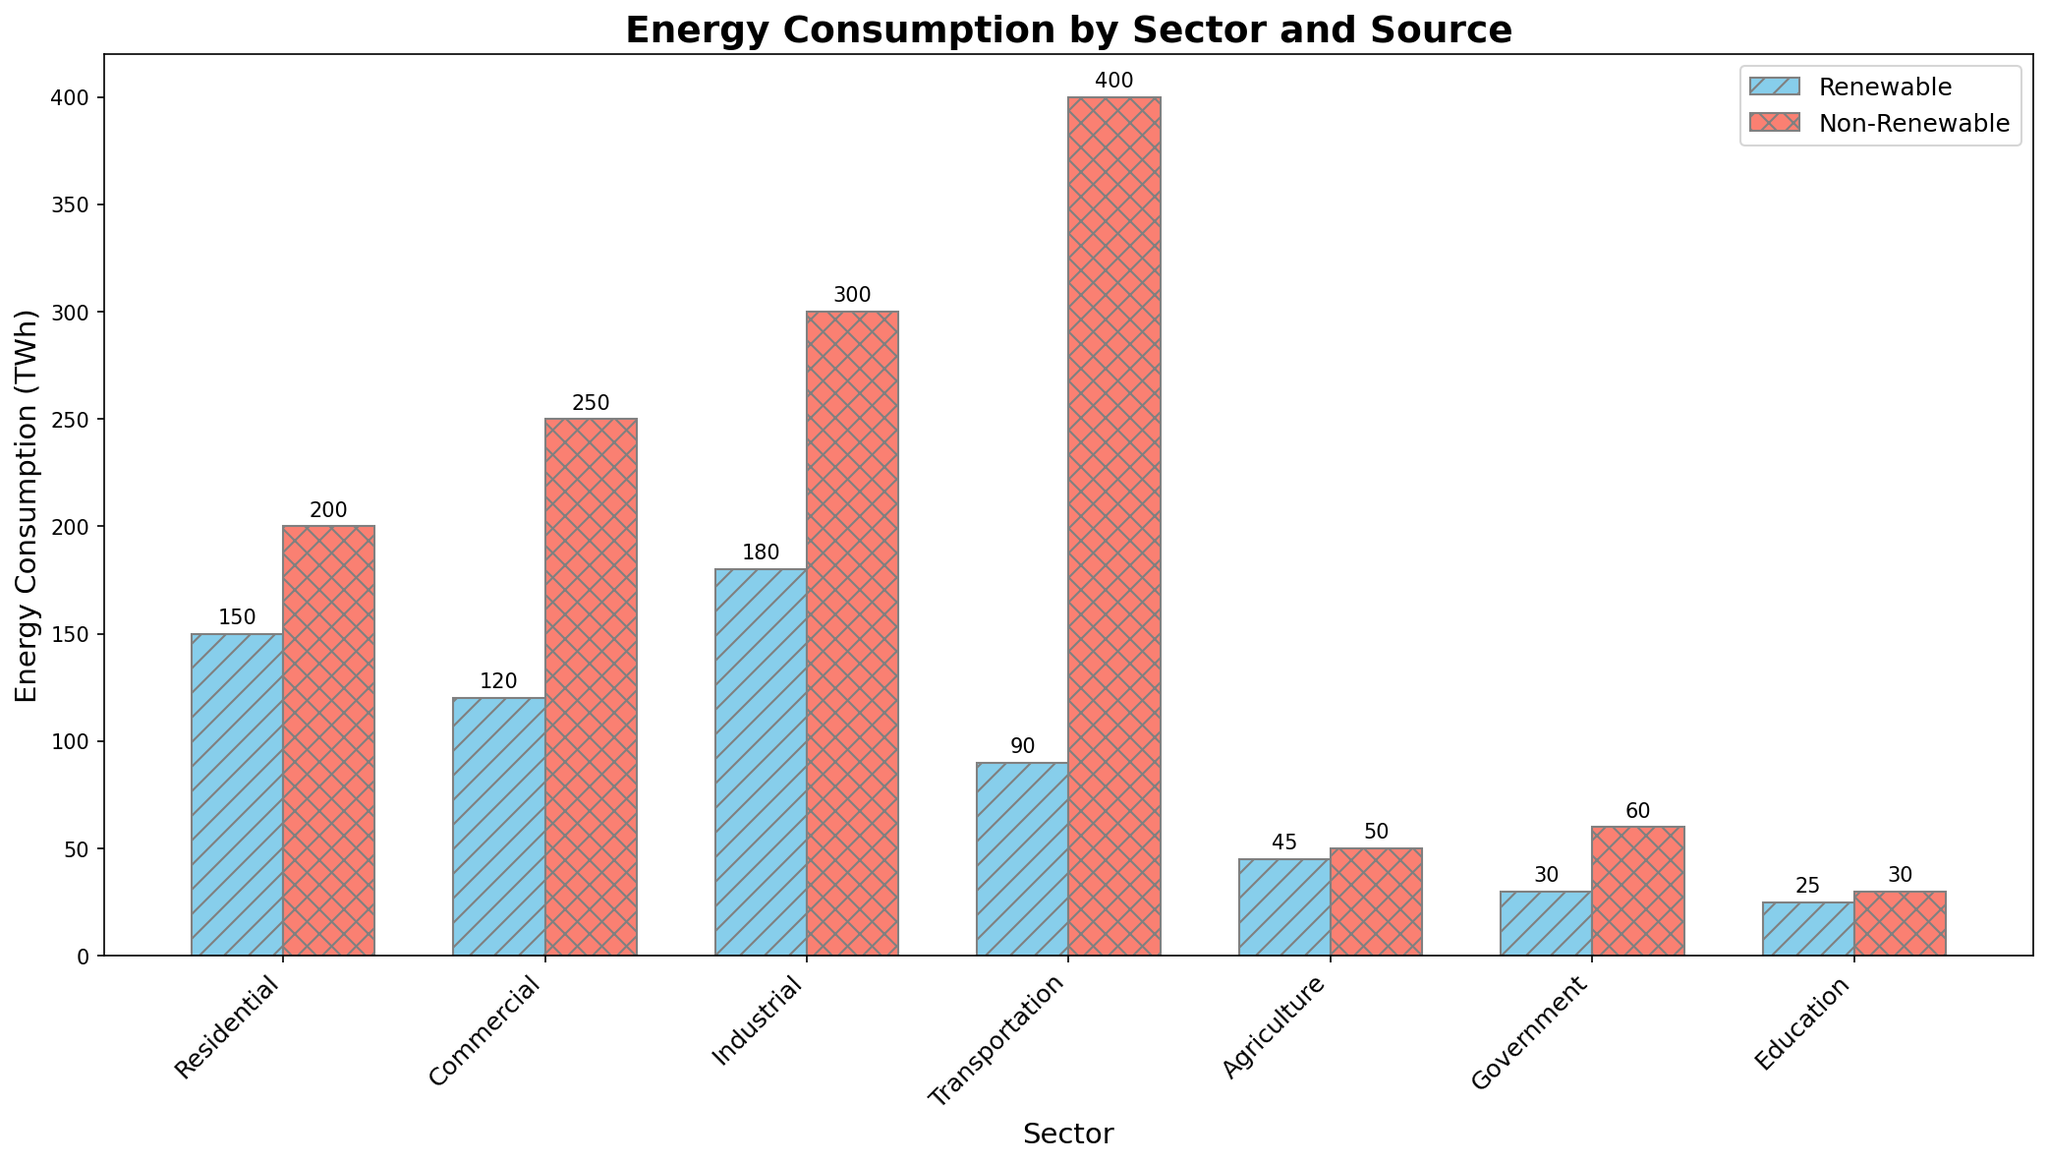Which sector has the highest non-renewable energy consumption? By visually inspecting the heights of the red bars (representing non-renewable energy) across all sectors, the Transportation sector has the highest bar.
Answer: Transportation What is the difference between the renewable and non-renewable energy consumption in the Industrial sector? From the given data, the renewable energy consumption in the Industrial sector is 180 TWh and non-renewable consumption is 300 TWh. The difference is 300 - 180 = 120 TWh.
Answer: 120 TWh How does the renewable energy consumption in the Residential sector compare to the Government sector? Visually, the blue bar for the Residential sector is much taller than that for the Government sector. Specifically, the Residential sector consumes 150 TWh of renewable energy, while the Government sector consumes 30 TWh.
Answer: Residential > Government In which sectors are the renewable energy consumption values higher than non-renewable? By comparing the heights of the blue and red bars in each sector, only the Agriculture sector has a higher renewable energy consumption (45 TWh) than non-renewable (50 TWh).
Answer: None 